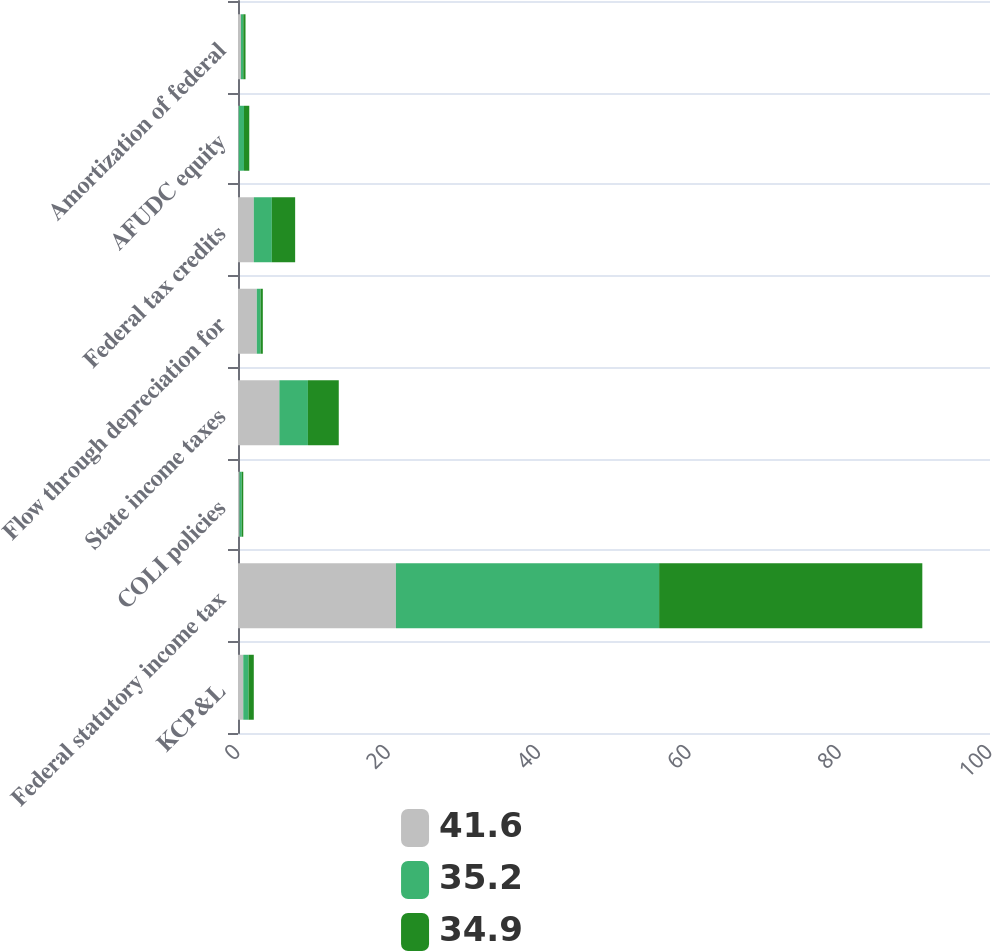Convert chart. <chart><loc_0><loc_0><loc_500><loc_500><stacked_bar_chart><ecel><fcel>KCP&L<fcel>Federal statutory income tax<fcel>COLI policies<fcel>State income taxes<fcel>Flow through depreciation for<fcel>Federal tax credits<fcel>AFUDC equity<fcel>Amortization of federal<nl><fcel>41.6<fcel>0.7<fcel>21<fcel>0.2<fcel>5.5<fcel>2.5<fcel>2.1<fcel>0.1<fcel>0.4<nl><fcel>35.2<fcel>0.7<fcel>35<fcel>0.3<fcel>3.8<fcel>0.5<fcel>2.4<fcel>0.7<fcel>0.3<nl><fcel>34.9<fcel>0.7<fcel>35<fcel>0.2<fcel>4.1<fcel>0.3<fcel>3.1<fcel>0.7<fcel>0.3<nl></chart> 